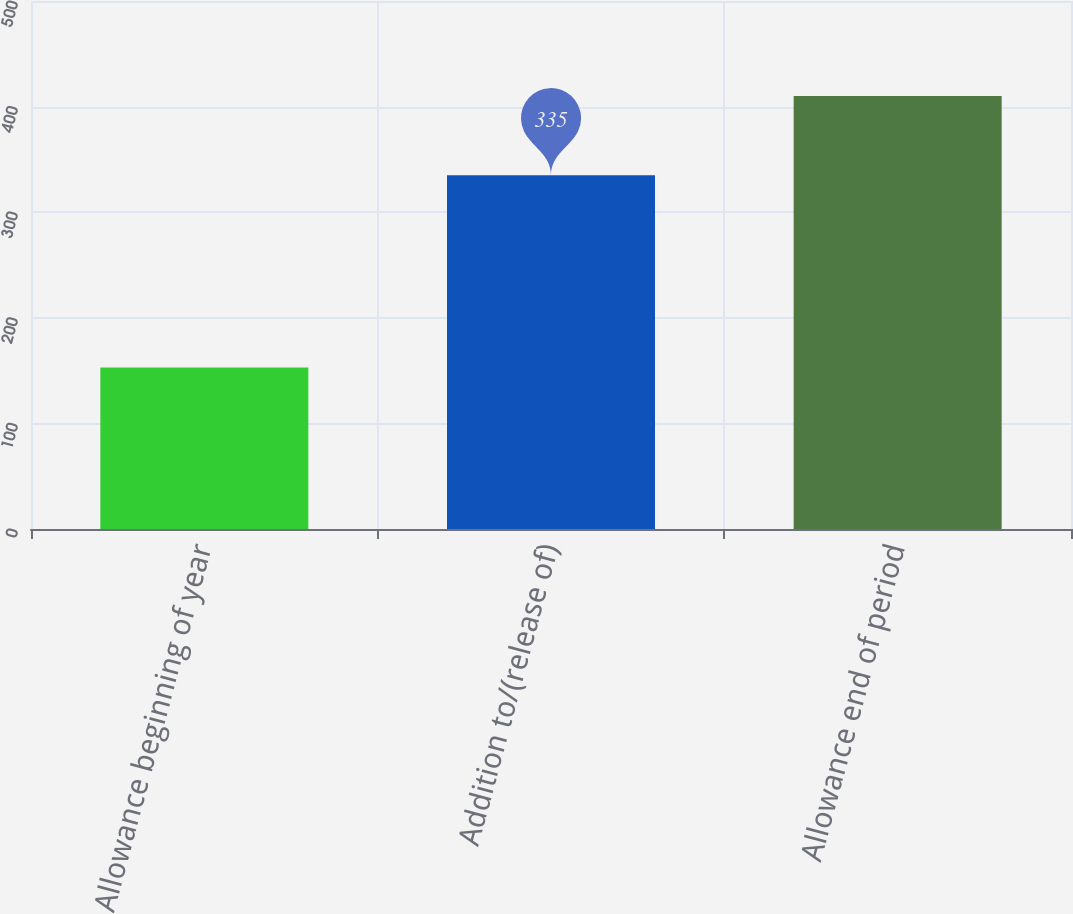<chart> <loc_0><loc_0><loc_500><loc_500><bar_chart><fcel>Allowance beginning of year<fcel>Addition to/(release of)<fcel>Allowance end of period<nl><fcel>153<fcel>335<fcel>410<nl></chart> 